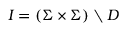<formula> <loc_0><loc_0><loc_500><loc_500>I = ( \Sigma \times \Sigma ) \ D</formula> 